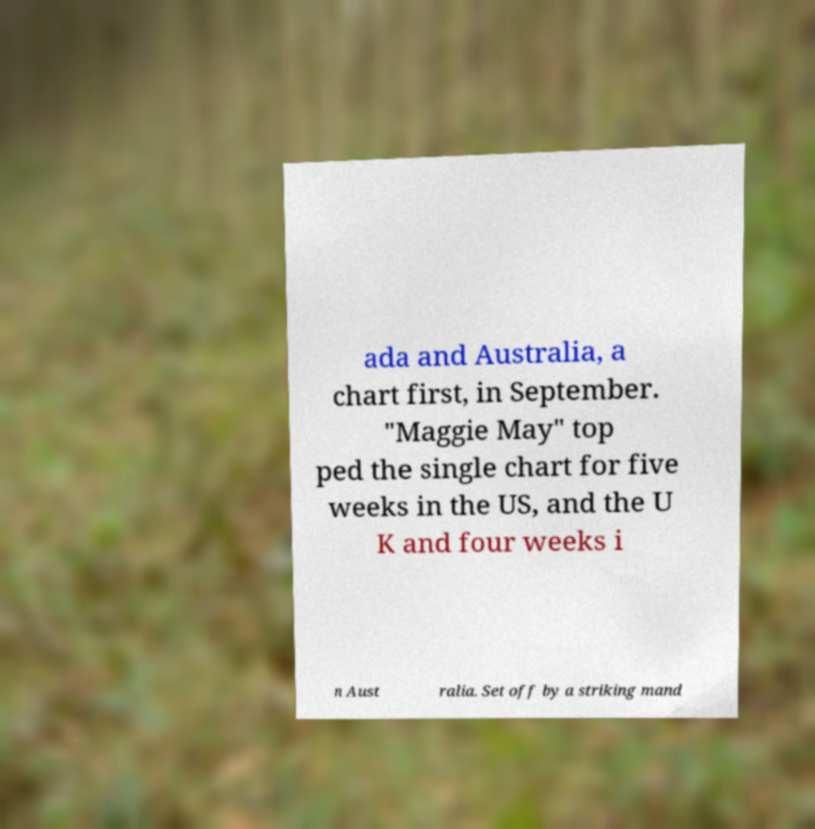Could you assist in decoding the text presented in this image and type it out clearly? ada and Australia, a chart first, in September. "Maggie May" top ped the single chart for five weeks in the US, and the U K and four weeks i n Aust ralia. Set off by a striking mand 